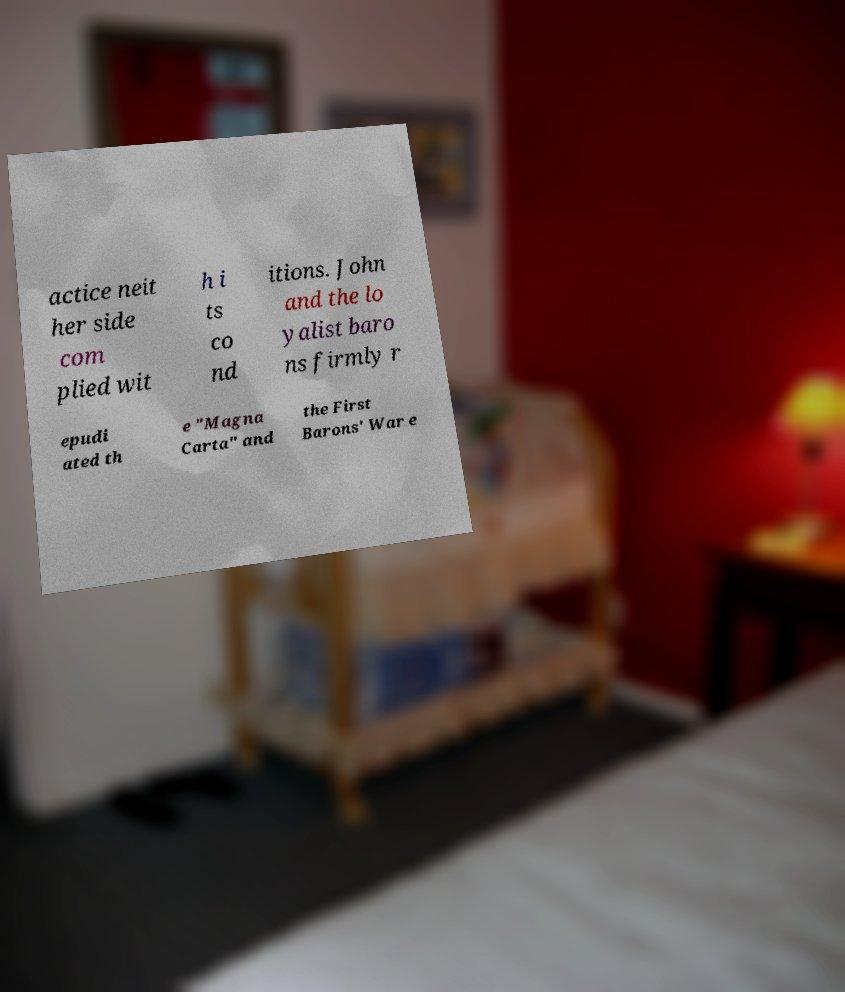Could you extract and type out the text from this image? actice neit her side com plied wit h i ts co nd itions. John and the lo yalist baro ns firmly r epudi ated th e "Magna Carta" and the First Barons' War e 